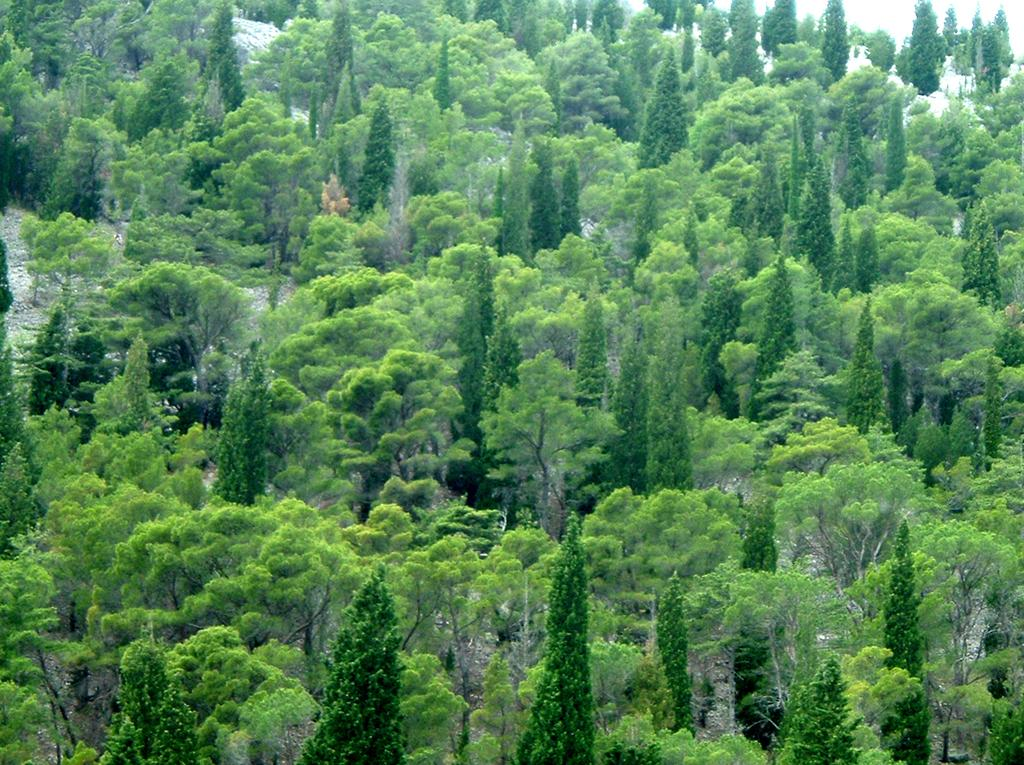What type of vegetation can be seen in the image? There are trees in the image. What advice is being given by the ice in the image? There is no ice present in the image, and therefore no advice can be given. 